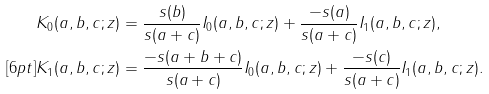Convert formula to latex. <formula><loc_0><loc_0><loc_500><loc_500>& K _ { 0 } ( a , b , c ; z ) = \frac { s ( b ) } { s ( a + c ) } I _ { 0 } ( a , b , c ; z ) + \frac { - s ( a ) } { s ( a + c ) } I _ { 1 } ( a , b , c ; z ) , \\ [ 6 p t ] & K _ { 1 } ( a , b , c ; z ) = \frac { - s ( a + b + c ) } { s ( a + c ) } I _ { 0 } ( a , b , c ; z ) + \frac { - s ( c ) } { s ( a + c ) } I _ { 1 } ( a , b , c ; z ) .</formula> 